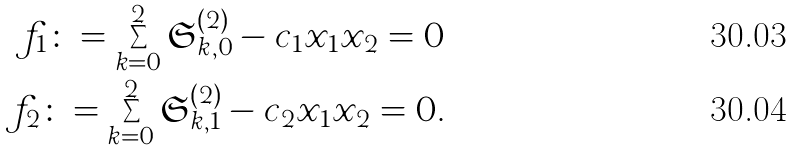<formula> <loc_0><loc_0><loc_500><loc_500>f _ { 1 } \colon = \sum _ { k = 0 } ^ { 2 } \mathfrak { S } ^ { ( 2 ) } _ { k , 0 } - c _ { 1 } x _ { 1 } x _ { 2 } = 0 \\ f _ { 2 } \colon = \sum _ { k = 0 } ^ { 2 } \mathfrak { S } ^ { ( 2 ) } _ { k , 1 } - c _ { 2 } x _ { 1 } x _ { 2 } = 0 .</formula> 